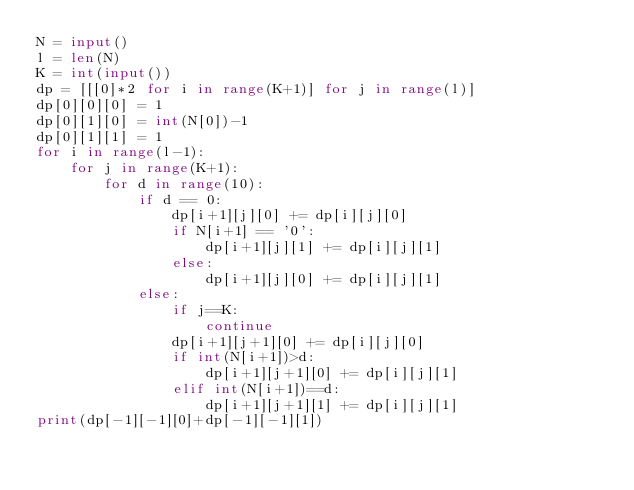Convert code to text. <code><loc_0><loc_0><loc_500><loc_500><_Python_>N = input()
l = len(N)
K = int(input())
dp = [[[0]*2 for i in range(K+1)] for j in range(l)]
dp[0][0][0] = 1
dp[0][1][0] = int(N[0])-1
dp[0][1][1] = 1
for i in range(l-1):
    for j in range(K+1):
        for d in range(10):
            if d == 0:
                dp[i+1][j][0] += dp[i][j][0]
                if N[i+1] == '0':
                    dp[i+1][j][1] += dp[i][j][1]
                else:
                    dp[i+1][j][0] += dp[i][j][1]
            else:
                if j==K:
                    continue
                dp[i+1][j+1][0] += dp[i][j][0]
                if int(N[i+1])>d:
                    dp[i+1][j+1][0] += dp[i][j][1]
                elif int(N[i+1])==d:
                    dp[i+1][j+1][1] += dp[i][j][1]
print(dp[-1][-1][0]+dp[-1][-1][1])



        
</code> 